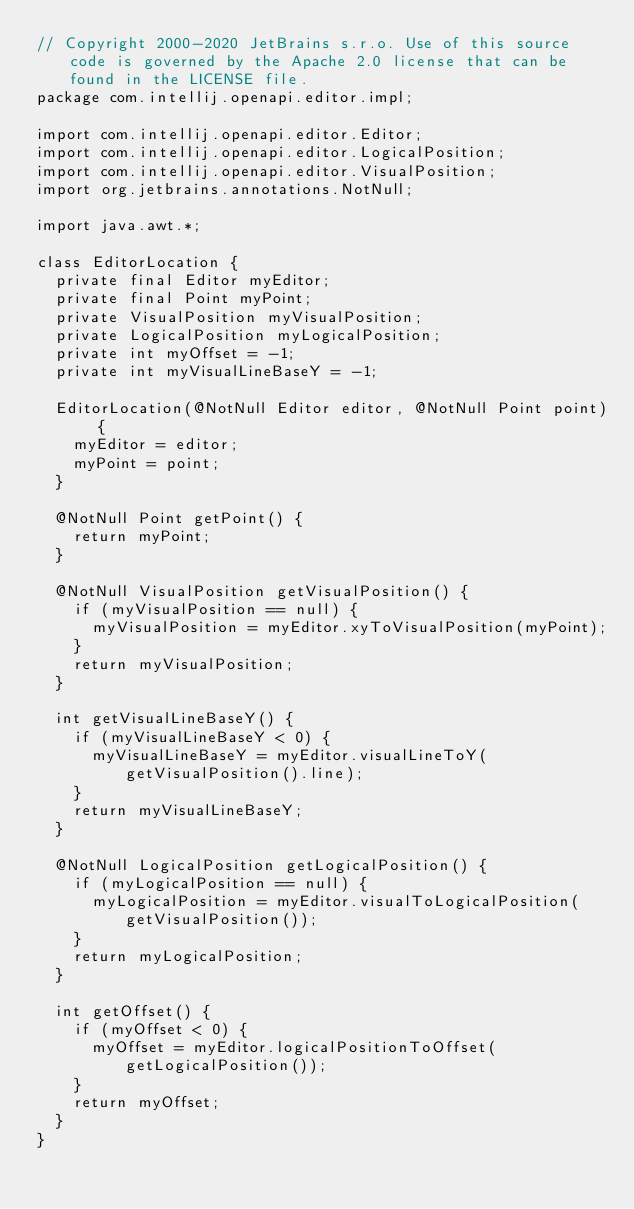<code> <loc_0><loc_0><loc_500><loc_500><_Java_>// Copyright 2000-2020 JetBrains s.r.o. Use of this source code is governed by the Apache 2.0 license that can be found in the LICENSE file.
package com.intellij.openapi.editor.impl;

import com.intellij.openapi.editor.Editor;
import com.intellij.openapi.editor.LogicalPosition;
import com.intellij.openapi.editor.VisualPosition;
import org.jetbrains.annotations.NotNull;

import java.awt.*;

class EditorLocation {
  private final Editor myEditor;
  private final Point myPoint;
  private VisualPosition myVisualPosition;
  private LogicalPosition myLogicalPosition;
  private int myOffset = -1;
  private int myVisualLineBaseY = -1;

  EditorLocation(@NotNull Editor editor, @NotNull Point point) {
    myEditor = editor;
    myPoint = point;
  }

  @NotNull Point getPoint() {
    return myPoint;
  }

  @NotNull VisualPosition getVisualPosition() {
    if (myVisualPosition == null) {
      myVisualPosition = myEditor.xyToVisualPosition(myPoint);
    }
    return myVisualPosition;
  }

  int getVisualLineBaseY() {
    if (myVisualLineBaseY < 0) {
      myVisualLineBaseY = myEditor.visualLineToY(getVisualPosition().line);
    }
    return myVisualLineBaseY;
  }

  @NotNull LogicalPosition getLogicalPosition() {
    if (myLogicalPosition == null) {
      myLogicalPosition = myEditor.visualToLogicalPosition(getVisualPosition());
    }
    return myLogicalPosition;
  }

  int getOffset() {
    if (myOffset < 0) {
      myOffset = myEditor.logicalPositionToOffset(getLogicalPosition());
    }
    return myOffset;
  }
}
</code> 